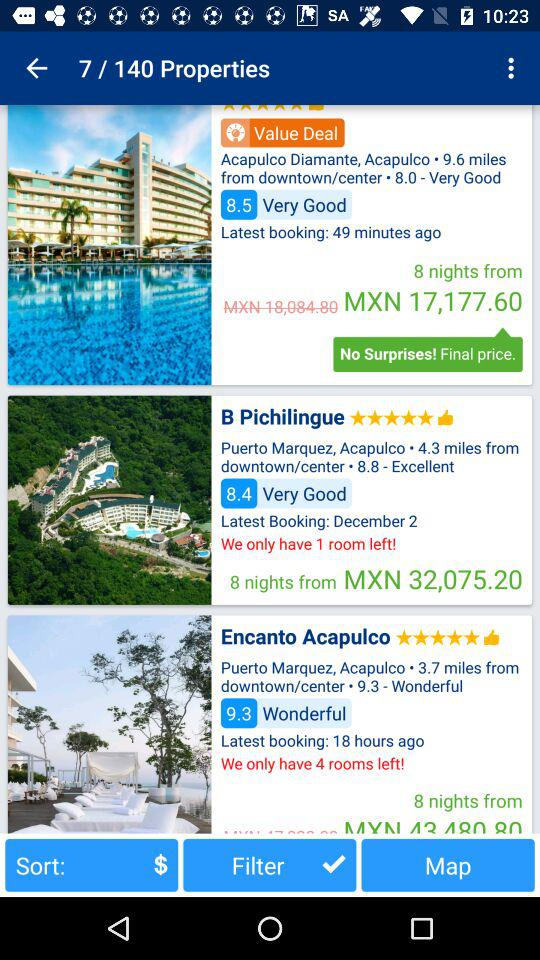How many rooms are left in "B Pichilingue"? There is 1 room left in "B Pichilingue". 